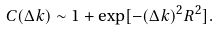Convert formula to latex. <formula><loc_0><loc_0><loc_500><loc_500>C ( \Delta k ) \sim 1 + \exp [ - ( \Delta k ) ^ { 2 } R ^ { 2 } ] .</formula> 